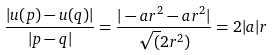<formula> <loc_0><loc_0><loc_500><loc_500>\frac { | u ( p ) - u ( q ) | } { | p - q | } = \frac { | - a r ^ { 2 } - a r ^ { 2 } | } { \sqrt { ( } 2 r ^ { 2 } ) } = 2 | a | r</formula> 